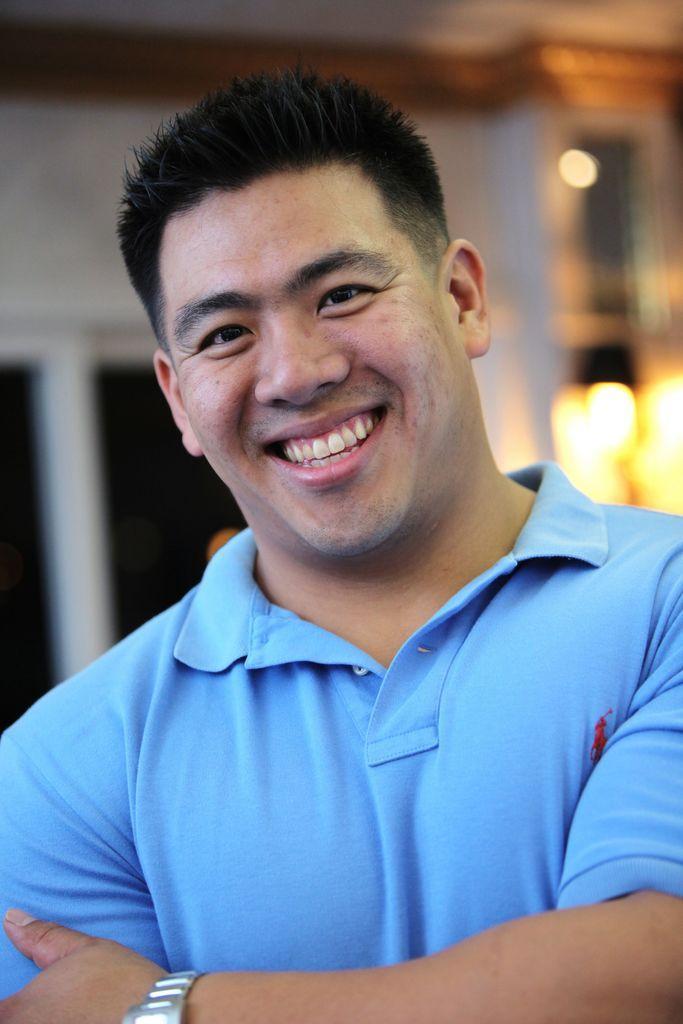In one or two sentences, can you explain what this image depicts? In this image I can see a man is smiling, he wore blue color t-shirt. 